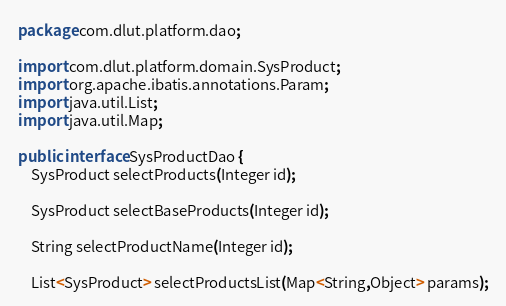Convert code to text. <code><loc_0><loc_0><loc_500><loc_500><_Java_>package com.dlut.platform.dao;

import com.dlut.platform.domain.SysProduct;
import org.apache.ibatis.annotations.Param;
import java.util.List;
import java.util.Map;

public interface SysProductDao {
    SysProduct selectProducts(Integer id);

    SysProduct selectBaseProducts(Integer id);

    String selectProductName(Integer id);

    List<SysProduct> selectProductsList(Map<String,Object> params);
</code> 